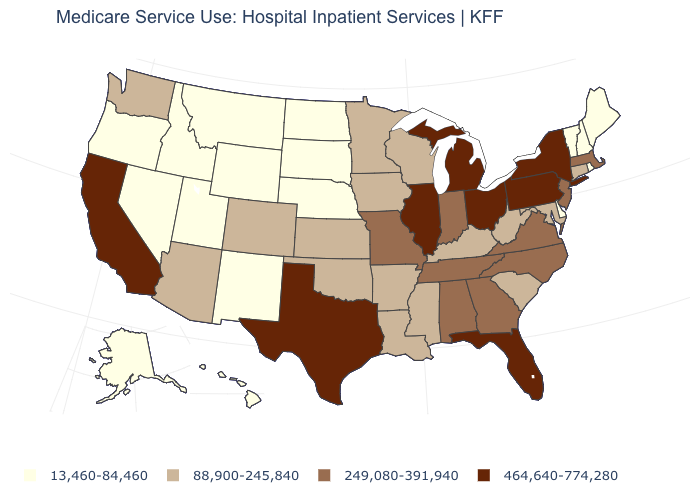What is the lowest value in the West?
Give a very brief answer. 13,460-84,460. What is the value of New Hampshire?
Give a very brief answer. 13,460-84,460. What is the highest value in the USA?
Short answer required. 464,640-774,280. What is the value of Massachusetts?
Short answer required. 249,080-391,940. Name the states that have a value in the range 88,900-245,840?
Short answer required. Arizona, Arkansas, Colorado, Connecticut, Iowa, Kansas, Kentucky, Louisiana, Maryland, Minnesota, Mississippi, Oklahoma, South Carolina, Washington, West Virginia, Wisconsin. What is the value of Minnesota?
Write a very short answer. 88,900-245,840. What is the value of Nebraska?
Give a very brief answer. 13,460-84,460. Which states hav the highest value in the South?
Answer briefly. Florida, Texas. Does West Virginia have a higher value than Vermont?
Answer briefly. Yes. How many symbols are there in the legend?
Quick response, please. 4. What is the value of Oklahoma?
Short answer required. 88,900-245,840. Does Louisiana have the highest value in the USA?
Keep it brief. No. What is the value of Ohio?
Concise answer only. 464,640-774,280. What is the value of Louisiana?
Short answer required. 88,900-245,840. What is the value of Maryland?
Be succinct. 88,900-245,840. 